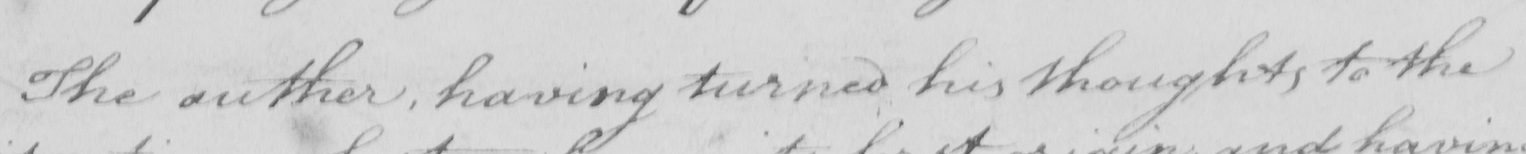What text is written in this handwritten line? The author , having turned his thoughts to the 